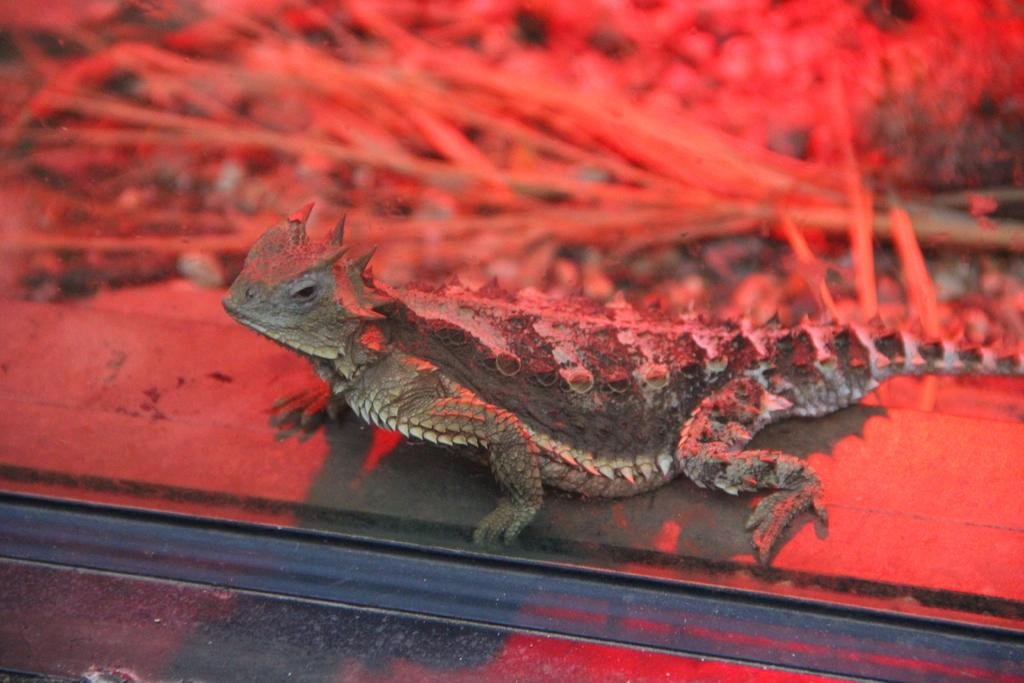What type of animal is present in the image? There is a lizard in the image. What color can be seen in the background of the image? There is a red color in the background of the image. What stage of development is the animal in the image? The image does not provide information about the development stage of the lizard. How does the animal in the image evoke disgust? The image does not evoke disgust, and there is no indication that the animal is meant to be disgusting. 